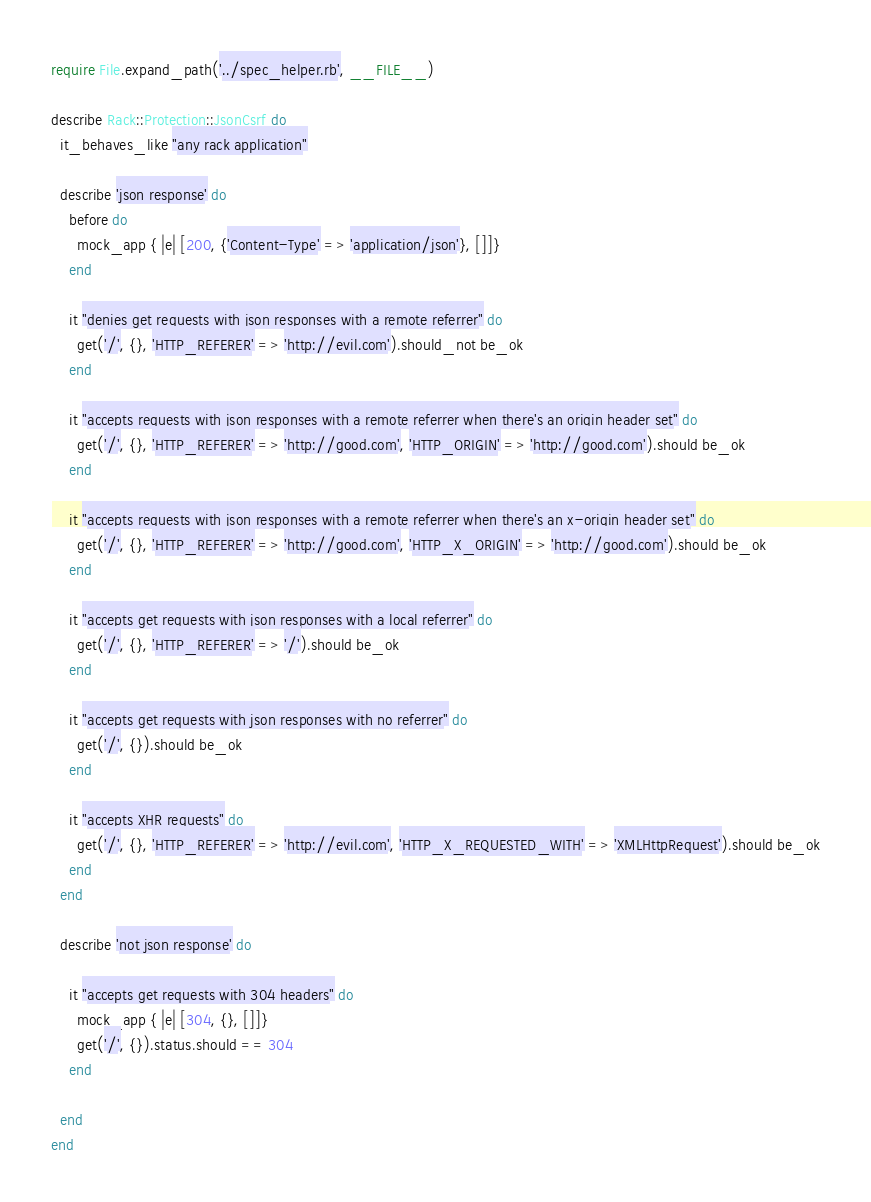<code> <loc_0><loc_0><loc_500><loc_500><_Ruby_>require File.expand_path('../spec_helper.rb', __FILE__)

describe Rack::Protection::JsonCsrf do
  it_behaves_like "any rack application"

  describe 'json response' do
    before do
      mock_app { |e| [200, {'Content-Type' => 'application/json'}, []]}
    end

    it "denies get requests with json responses with a remote referrer" do
      get('/', {}, 'HTTP_REFERER' => 'http://evil.com').should_not be_ok
    end

    it "accepts requests with json responses with a remote referrer when there's an origin header set" do
      get('/', {}, 'HTTP_REFERER' => 'http://good.com', 'HTTP_ORIGIN' => 'http://good.com').should be_ok
    end

    it "accepts requests with json responses with a remote referrer when there's an x-origin header set" do
      get('/', {}, 'HTTP_REFERER' => 'http://good.com', 'HTTP_X_ORIGIN' => 'http://good.com').should be_ok
    end

    it "accepts get requests with json responses with a local referrer" do
      get('/', {}, 'HTTP_REFERER' => '/').should be_ok
    end

    it "accepts get requests with json responses with no referrer" do
      get('/', {}).should be_ok
    end

    it "accepts XHR requests" do
      get('/', {}, 'HTTP_REFERER' => 'http://evil.com', 'HTTP_X_REQUESTED_WITH' => 'XMLHttpRequest').should be_ok
    end
  end

  describe 'not json response' do

    it "accepts get requests with 304 headers" do
      mock_app { |e| [304, {}, []]}
      get('/', {}).status.should == 304
    end

  end
end
</code> 